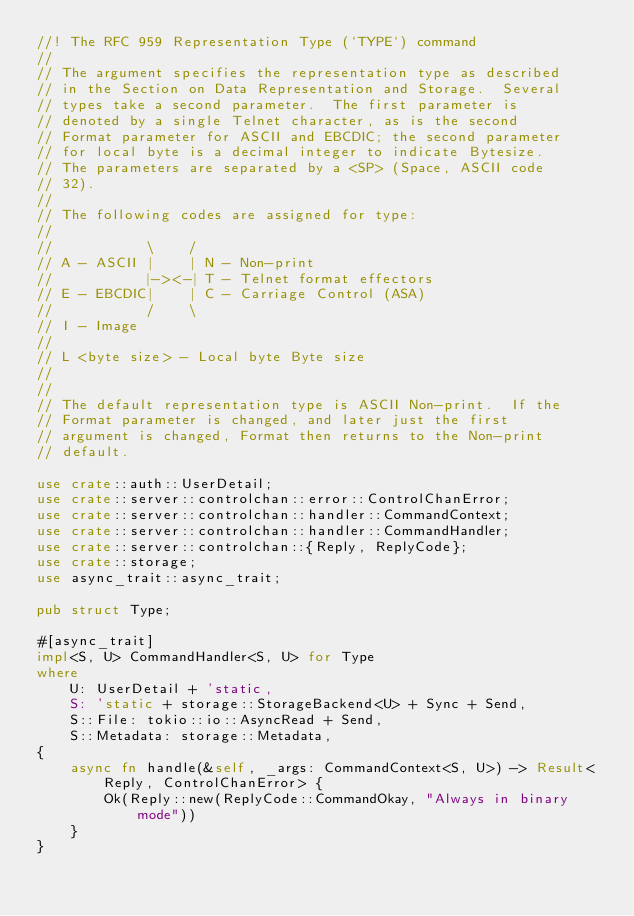Convert code to text. <code><loc_0><loc_0><loc_500><loc_500><_Rust_>//! The RFC 959 Representation Type (`TYPE`) command
//
// The argument specifies the representation type as described
// in the Section on Data Representation and Storage.  Several
// types take a second parameter.  The first parameter is
// denoted by a single Telnet character, as is the second
// Format parameter for ASCII and EBCDIC; the second parameter
// for local byte is a decimal integer to indicate Bytesize.
// The parameters are separated by a <SP> (Space, ASCII code
// 32).
//
// The following codes are assigned for type:
//
//           \    /
// A - ASCII |    | N - Non-print
//           |-><-| T - Telnet format effectors
// E - EBCDIC|    | C - Carriage Control (ASA)
//           /    \
// I - Image
//
// L <byte size> - Local byte Byte size
//
//
// The default representation type is ASCII Non-print.  If the
// Format parameter is changed, and later just the first
// argument is changed, Format then returns to the Non-print
// default.

use crate::auth::UserDetail;
use crate::server::controlchan::error::ControlChanError;
use crate::server::controlchan::handler::CommandContext;
use crate::server::controlchan::handler::CommandHandler;
use crate::server::controlchan::{Reply, ReplyCode};
use crate::storage;
use async_trait::async_trait;

pub struct Type;

#[async_trait]
impl<S, U> CommandHandler<S, U> for Type
where
    U: UserDetail + 'static,
    S: 'static + storage::StorageBackend<U> + Sync + Send,
    S::File: tokio::io::AsyncRead + Send,
    S::Metadata: storage::Metadata,
{
    async fn handle(&self, _args: CommandContext<S, U>) -> Result<Reply, ControlChanError> {
        Ok(Reply::new(ReplyCode::CommandOkay, "Always in binary mode"))
    }
}
</code> 